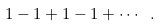Convert formula to latex. <formula><loc_0><loc_0><loc_500><loc_500>1 - 1 + 1 - 1 + \cdots \ .</formula> 